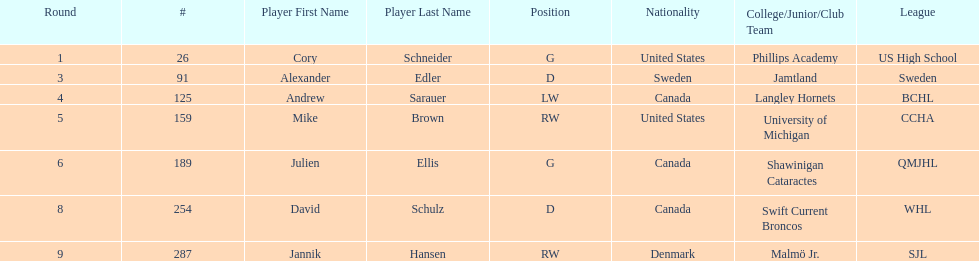Who is the only player to have denmark listed as their nationality? Jannik Hansen (RW). 